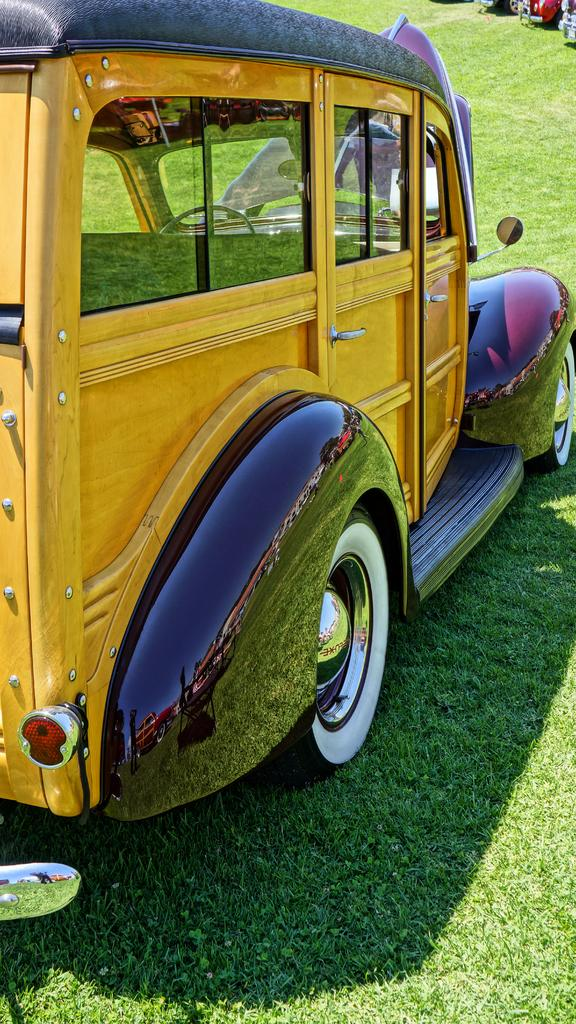What is the main subject in the center of the image? There is a van in the center of the image. What type of environment surrounds the area in the image? There is grassland surrounding the area of the image. What type of wire can be seen connecting the van to the grassland? There is no wire connecting the van to the grassland in the image. 